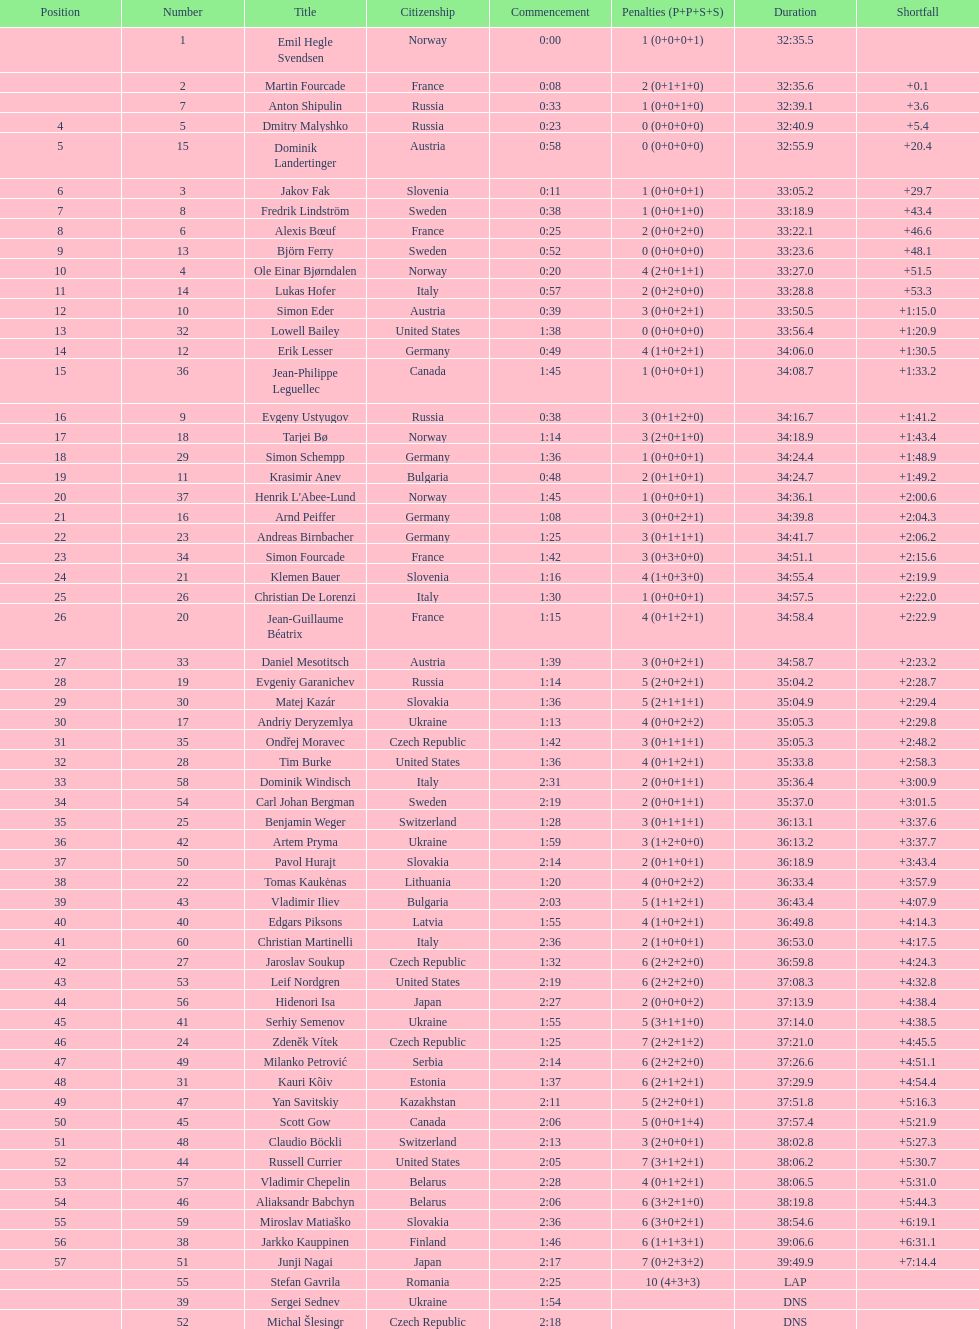Parse the full table. {'header': ['Position', 'Number', 'Title', 'Citizenship', 'Commencement', 'Penalties (P+P+S+S)', 'Duration', 'Shortfall'], 'rows': [['', '1', 'Emil Hegle Svendsen', 'Norway', '0:00', '1 (0+0+0+1)', '32:35.5', ''], ['', '2', 'Martin Fourcade', 'France', '0:08', '2 (0+1+1+0)', '32:35.6', '+0.1'], ['', '7', 'Anton Shipulin', 'Russia', '0:33', '1 (0+0+1+0)', '32:39.1', '+3.6'], ['4', '5', 'Dmitry Malyshko', 'Russia', '0:23', '0 (0+0+0+0)', '32:40.9', '+5.4'], ['5', '15', 'Dominik Landertinger', 'Austria', '0:58', '0 (0+0+0+0)', '32:55.9', '+20.4'], ['6', '3', 'Jakov Fak', 'Slovenia', '0:11', '1 (0+0+0+1)', '33:05.2', '+29.7'], ['7', '8', 'Fredrik Lindström', 'Sweden', '0:38', '1 (0+0+1+0)', '33:18.9', '+43.4'], ['8', '6', 'Alexis Bœuf', 'France', '0:25', '2 (0+0+2+0)', '33:22.1', '+46.6'], ['9', '13', 'Björn Ferry', 'Sweden', '0:52', '0 (0+0+0+0)', '33:23.6', '+48.1'], ['10', '4', 'Ole Einar Bjørndalen', 'Norway', '0:20', '4 (2+0+1+1)', '33:27.0', '+51.5'], ['11', '14', 'Lukas Hofer', 'Italy', '0:57', '2 (0+2+0+0)', '33:28.8', '+53.3'], ['12', '10', 'Simon Eder', 'Austria', '0:39', '3 (0+0+2+1)', '33:50.5', '+1:15.0'], ['13', '32', 'Lowell Bailey', 'United States', '1:38', '0 (0+0+0+0)', '33:56.4', '+1:20.9'], ['14', '12', 'Erik Lesser', 'Germany', '0:49', '4 (1+0+2+1)', '34:06.0', '+1:30.5'], ['15', '36', 'Jean-Philippe Leguellec', 'Canada', '1:45', '1 (0+0+0+1)', '34:08.7', '+1:33.2'], ['16', '9', 'Evgeny Ustyugov', 'Russia', '0:38', '3 (0+1+2+0)', '34:16.7', '+1:41.2'], ['17', '18', 'Tarjei Bø', 'Norway', '1:14', '3 (2+0+1+0)', '34:18.9', '+1:43.4'], ['18', '29', 'Simon Schempp', 'Germany', '1:36', '1 (0+0+0+1)', '34:24.4', '+1:48.9'], ['19', '11', 'Krasimir Anev', 'Bulgaria', '0:48', '2 (0+1+0+1)', '34:24.7', '+1:49.2'], ['20', '37', "Henrik L'Abee-Lund", 'Norway', '1:45', '1 (0+0+0+1)', '34:36.1', '+2:00.6'], ['21', '16', 'Arnd Peiffer', 'Germany', '1:08', '3 (0+0+2+1)', '34:39.8', '+2:04.3'], ['22', '23', 'Andreas Birnbacher', 'Germany', '1:25', '3 (0+1+1+1)', '34:41.7', '+2:06.2'], ['23', '34', 'Simon Fourcade', 'France', '1:42', '3 (0+3+0+0)', '34:51.1', '+2:15.6'], ['24', '21', 'Klemen Bauer', 'Slovenia', '1:16', '4 (1+0+3+0)', '34:55.4', '+2:19.9'], ['25', '26', 'Christian De Lorenzi', 'Italy', '1:30', '1 (0+0+0+1)', '34:57.5', '+2:22.0'], ['26', '20', 'Jean-Guillaume Béatrix', 'France', '1:15', '4 (0+1+2+1)', '34:58.4', '+2:22.9'], ['27', '33', 'Daniel Mesotitsch', 'Austria', '1:39', '3 (0+0+2+1)', '34:58.7', '+2:23.2'], ['28', '19', 'Evgeniy Garanichev', 'Russia', '1:14', '5 (2+0+2+1)', '35:04.2', '+2:28.7'], ['29', '30', 'Matej Kazár', 'Slovakia', '1:36', '5 (2+1+1+1)', '35:04.9', '+2:29.4'], ['30', '17', 'Andriy Deryzemlya', 'Ukraine', '1:13', '4 (0+0+2+2)', '35:05.3', '+2:29.8'], ['31', '35', 'Ondřej Moravec', 'Czech Republic', '1:42', '3 (0+1+1+1)', '35:05.3', '+2:48.2'], ['32', '28', 'Tim Burke', 'United States', '1:36', '4 (0+1+2+1)', '35:33.8', '+2:58.3'], ['33', '58', 'Dominik Windisch', 'Italy', '2:31', '2 (0+0+1+1)', '35:36.4', '+3:00.9'], ['34', '54', 'Carl Johan Bergman', 'Sweden', '2:19', '2 (0+0+1+1)', '35:37.0', '+3:01.5'], ['35', '25', 'Benjamin Weger', 'Switzerland', '1:28', '3 (0+1+1+1)', '36:13.1', '+3:37.6'], ['36', '42', 'Artem Pryma', 'Ukraine', '1:59', '3 (1+2+0+0)', '36:13.2', '+3:37.7'], ['37', '50', 'Pavol Hurajt', 'Slovakia', '2:14', '2 (0+1+0+1)', '36:18.9', '+3:43.4'], ['38', '22', 'Tomas Kaukėnas', 'Lithuania', '1:20', '4 (0+0+2+2)', '36:33.4', '+3:57.9'], ['39', '43', 'Vladimir Iliev', 'Bulgaria', '2:03', '5 (1+1+2+1)', '36:43.4', '+4:07.9'], ['40', '40', 'Edgars Piksons', 'Latvia', '1:55', '4 (1+0+2+1)', '36:49.8', '+4:14.3'], ['41', '60', 'Christian Martinelli', 'Italy', '2:36', '2 (1+0+0+1)', '36:53.0', '+4:17.5'], ['42', '27', 'Jaroslav Soukup', 'Czech Republic', '1:32', '6 (2+2+2+0)', '36:59.8', '+4:24.3'], ['43', '53', 'Leif Nordgren', 'United States', '2:19', '6 (2+2+2+0)', '37:08.3', '+4:32.8'], ['44', '56', 'Hidenori Isa', 'Japan', '2:27', '2 (0+0+0+2)', '37:13.9', '+4:38.4'], ['45', '41', 'Serhiy Semenov', 'Ukraine', '1:55', '5 (3+1+1+0)', '37:14.0', '+4:38.5'], ['46', '24', 'Zdeněk Vítek', 'Czech Republic', '1:25', '7 (2+2+1+2)', '37:21.0', '+4:45.5'], ['47', '49', 'Milanko Petrović', 'Serbia', '2:14', '6 (2+2+2+0)', '37:26.6', '+4:51.1'], ['48', '31', 'Kauri Kõiv', 'Estonia', '1:37', '6 (2+1+2+1)', '37:29.9', '+4:54.4'], ['49', '47', 'Yan Savitskiy', 'Kazakhstan', '2:11', '5 (2+2+0+1)', '37:51.8', '+5:16.3'], ['50', '45', 'Scott Gow', 'Canada', '2:06', '5 (0+0+1+4)', '37:57.4', '+5:21.9'], ['51', '48', 'Claudio Böckli', 'Switzerland', '2:13', '3 (2+0+0+1)', '38:02.8', '+5:27.3'], ['52', '44', 'Russell Currier', 'United States', '2:05', '7 (3+1+2+1)', '38:06.2', '+5:30.7'], ['53', '57', 'Vladimir Chepelin', 'Belarus', '2:28', '4 (0+1+2+1)', '38:06.5', '+5:31.0'], ['54', '46', 'Aliaksandr Babchyn', 'Belarus', '2:06', '6 (3+2+1+0)', '38:19.8', '+5:44.3'], ['55', '59', 'Miroslav Matiaško', 'Slovakia', '2:36', '6 (3+0+2+1)', '38:54.6', '+6:19.1'], ['56', '38', 'Jarkko Kauppinen', 'Finland', '1:46', '6 (1+1+3+1)', '39:06.6', '+6:31.1'], ['57', '51', 'Junji Nagai', 'Japan', '2:17', '7 (0+2+3+2)', '39:49.9', '+7:14.4'], ['', '55', 'Stefan Gavrila', 'Romania', '2:25', '10 (4+3+3)', 'LAP', ''], ['', '39', 'Sergei Sednev', 'Ukraine', '1:54', '', 'DNS', ''], ['', '52', 'Michal Šlesingr', 'Czech Republic', '2:18', '', 'DNS', '']]} How many individuals finished with a time of 35:00 or more? 30. 